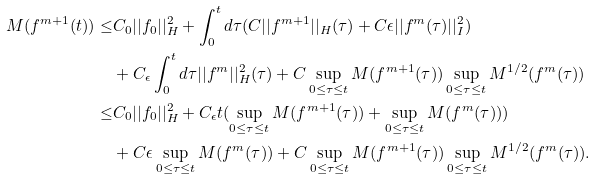Convert formula to latex. <formula><loc_0><loc_0><loc_500><loc_500>M ( f ^ { m + 1 } ( t ) ) \leq & C _ { 0 } | | f _ { 0 } | | ^ { 2 } _ { H } + \int _ { 0 } ^ { t } d \tau ( C | | f ^ { m + 1 } | | _ { H } ( \tau ) + C \epsilon | | f ^ { m } ( \tau ) | | ^ { 2 } _ { I } ) \\ & + C _ { \epsilon } \int _ { 0 } ^ { t } d \tau | | f ^ { m } | | ^ { 2 } _ { H } ( \tau ) + C \sup _ { 0 \leq \tau \leq t } M ( f ^ { m + 1 } ( \tau ) ) \sup _ { 0 \leq \tau \leq t } M ^ { 1 / 2 } ( f ^ { m } ( \tau ) ) \\ \leq & C _ { 0 } | | f _ { 0 } | | ^ { 2 } _ { H } + C _ { \epsilon } t ( \sup _ { 0 \leq \tau \leq t } M ( f ^ { m + 1 } ( \tau ) ) + \sup _ { 0 \leq \tau \leq t } M ( f ^ { m } ( \tau ) ) ) \\ & + C \epsilon \sup _ { 0 \leq \tau \leq t } M ( f ^ { m } ( \tau ) ) + C \sup _ { 0 \leq \tau \leq t } M ( f ^ { m + 1 } ( \tau ) ) \sup _ { 0 \leq \tau \leq t } M ^ { 1 / 2 } ( f ^ { m } ( \tau ) ) .</formula> 